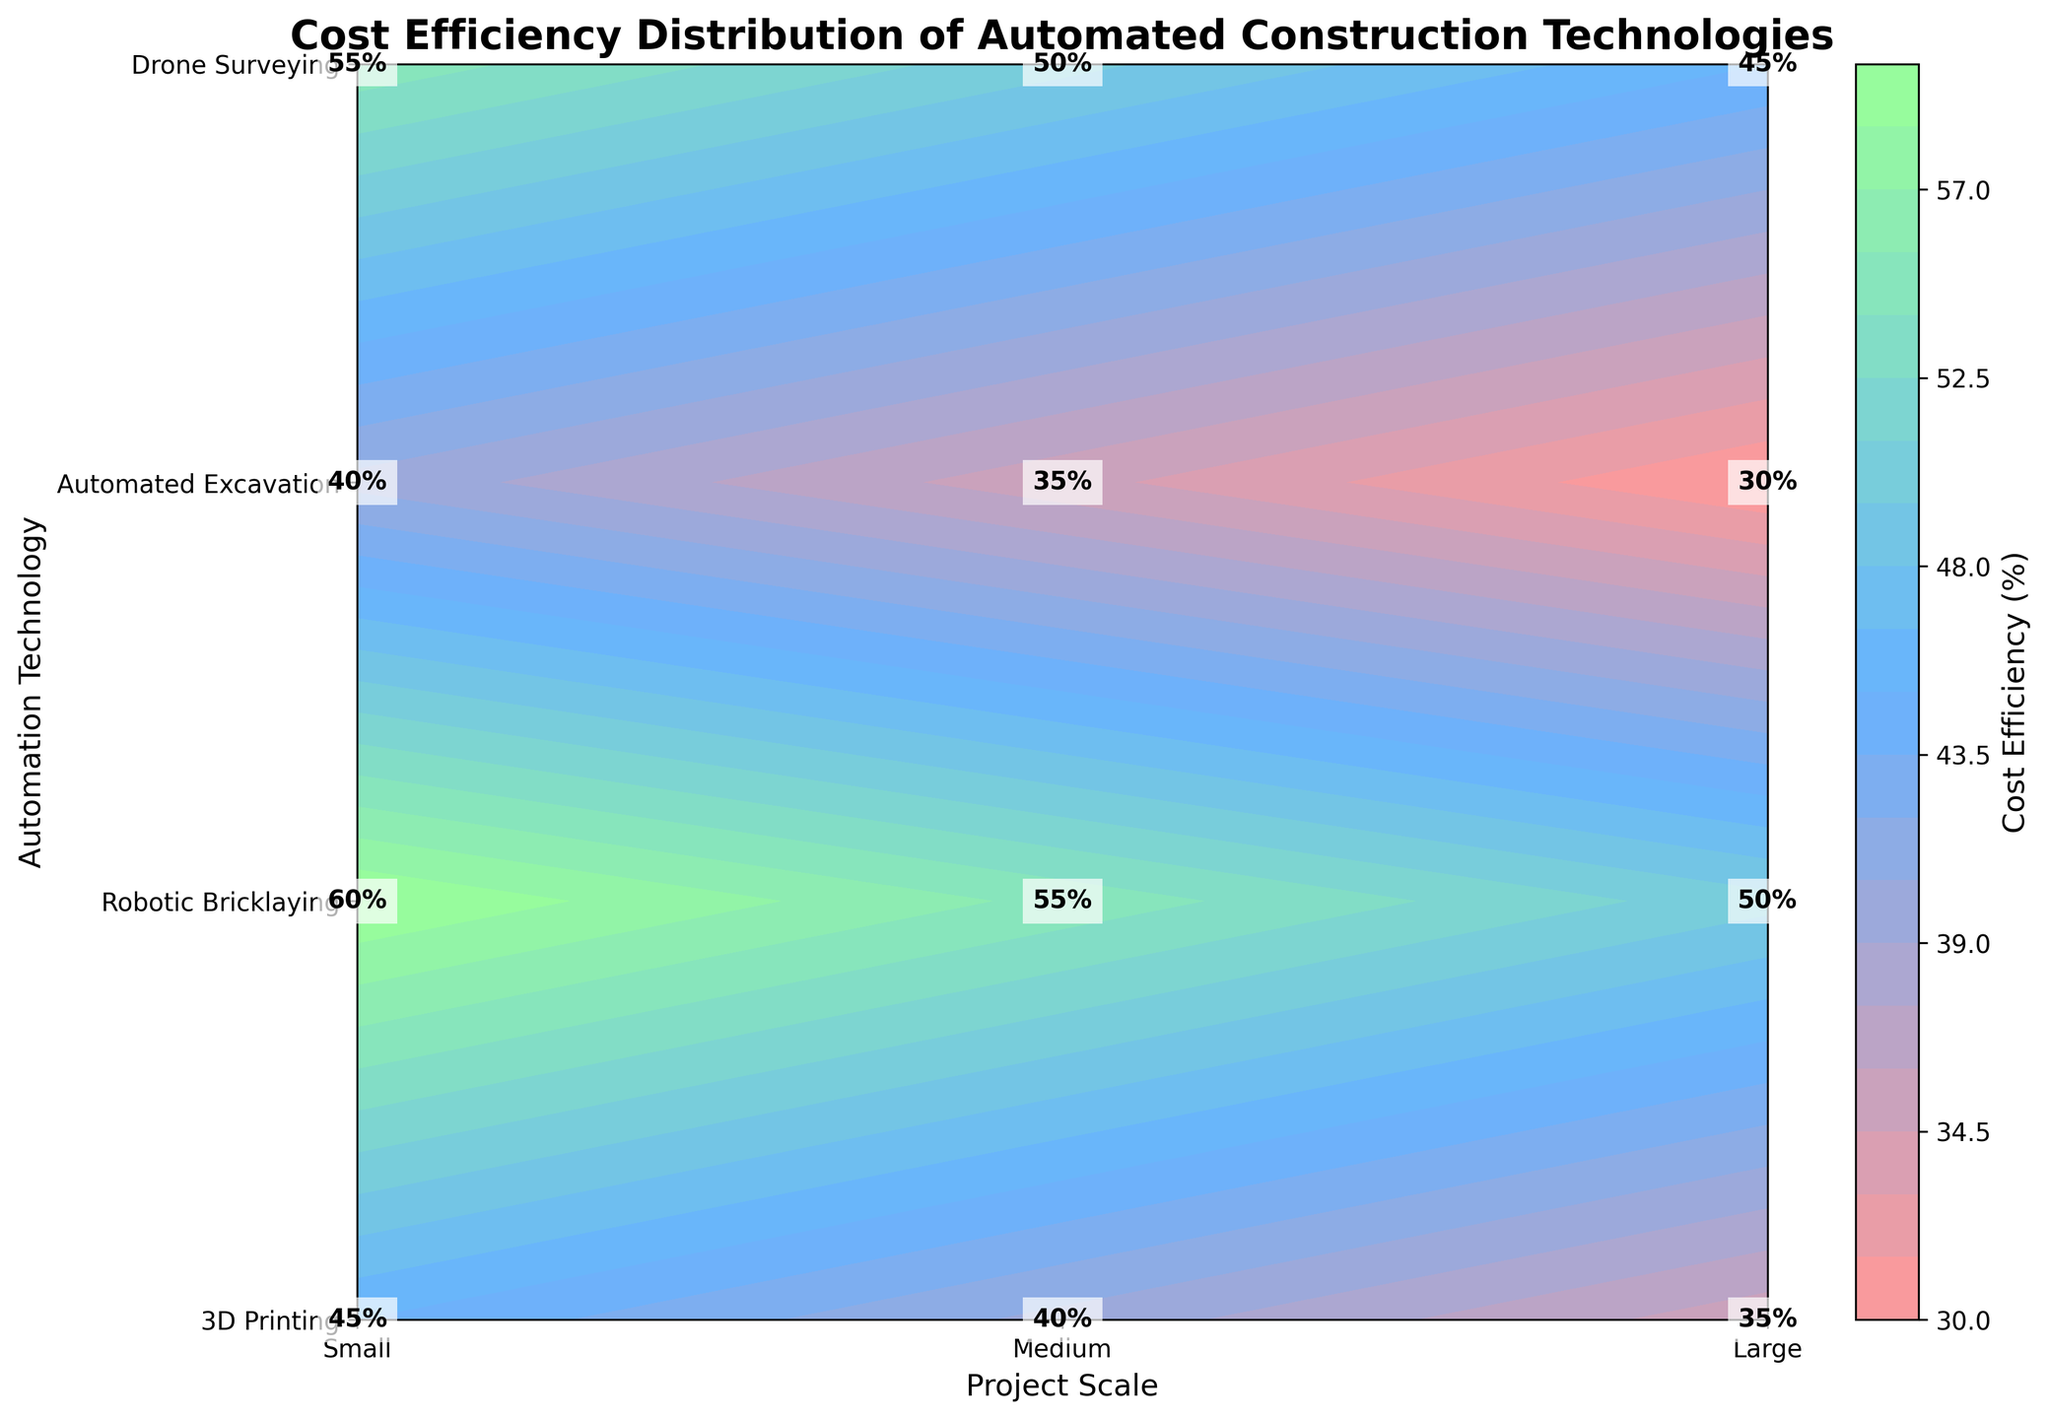What is the title of the plot? The title is usually located at the top of the plot. In this case, the title is "Cost Efficiency Distribution of Automated Construction Technologies."
Answer: Cost Efficiency Distribution of Automated Construction Technologies What does the color bar label indicate? The label on the color bar represents what the color scale measures. Here, it indicates "Cost Efficiency (%)".
Answer: Cost Efficiency (%) Which automation technology has the highest cost efficiency in large-scale projects? Locate the row corresponding to the large-scale projects and identify the highest value. For large-scale projects: 3D Printing (45%), Robotic Bricklaying (55%), Automated Excavation (60%), Drone Surveying (40%). Automated Excavation has the highest cost efficiency at 60%.
Answer: Automated Excavation What is the cost efficiency of Drone Surveying for medium-scale projects? Find the intersection of Drone Surveying technology and medium-scale projects. The value at the intersection is 35%.
Answer: 35% Which project scale generally shows the highest cost efficiency across all technologies? Compare the average cost efficiency values for small, medium, and large scales:
Small: (35% + 45% + 50% + 30%)/4 = 40%
Medium: (40% + 50% + 55% + 35%)/4 = 45%
Large: (45% + 55% + 60% + 40%)/4 = 50%
Large-scale projects have the highest average cost efficiency.
Answer: Large How does the cost efficiency of 3D Printing change from small to large project scales? Look at the values for 3D Printing across different scales. Small: 35%, Medium: 40%, Large: 45%. The cost efficiency increases by 5% for each scale from small to large.
Answer: It increases Compare the cost efficiency of Robotic Bricklaying and Drone Surveying for small projects. Check the values for small-scale projects: Robotic Bricklaying has 45%, and Drone Surveying has 30%. Robotic Bricklaying has a 15% higher cost efficiency than Drone Surveying.
Answer: Robotic Bricklaying is higher How many and which project scales are labeled on the x-axis? The x-axis represents the project scales, which are labeled as small, medium, and large. There are three project scales.
Answer: Three (Small, Medium, Large) What's the average cost efficiency of all automation technologies for medium projects? Calculate the average of cost efficiencies for medium-scale projects: 
(40% + 50% + 55% + 35%) / 4 = 180% / 4 = 45%.
The average cost efficiency for medium projects is 45%.
Answer: 45% Which automation technology has the most significant improvement in cost efficiency from small to medium projects? Calculate the differences:
3D Printing: 40% - 35% = 5%
Robotic Bricklaying: 50% - 45% = 5%
Automated Excavation: 55% - 50% = 5%
Drone Surveying: 35% - 30% = 5%
All technologies show an equal improvement of 5%.
Answer: All technologies have the same improvement 